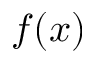<formula> <loc_0><loc_0><loc_500><loc_500>f ( \boldsymbol x )</formula> 